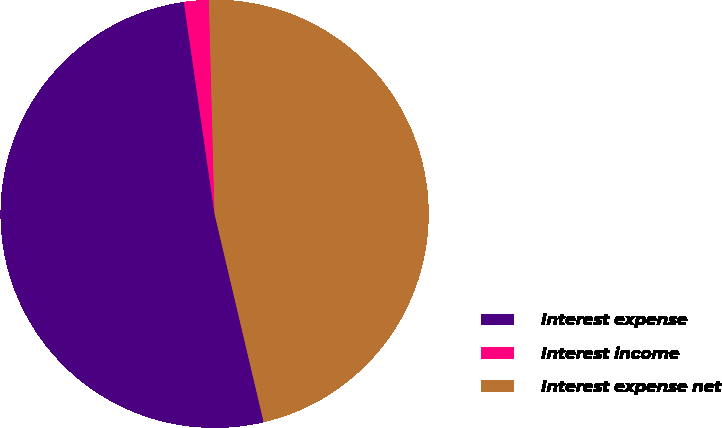<chart> <loc_0><loc_0><loc_500><loc_500><pie_chart><fcel>Interest expense<fcel>Interest income<fcel>Interest expense net<nl><fcel>51.4%<fcel>1.87%<fcel>46.73%<nl></chart> 